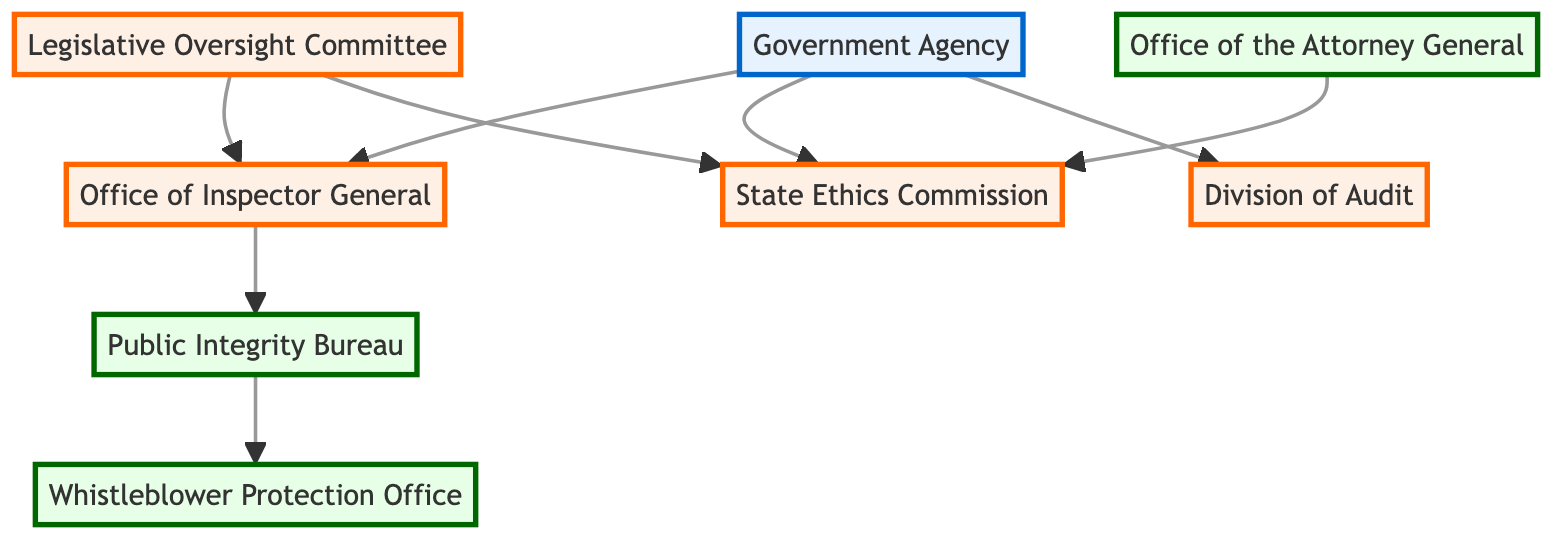What is the total number of nodes in the diagram? By counting each distinct node listed in the data, there are 8 nodes: Government Agency, Office of Inspector General, State Ethics Commission, Division of Audit, Legislative Oversight Committee, Whistleblower Protection Office, Public Integrity Bureau, and Office of the Attorney General.
Answer: 8 Which office reports directly to the Government Agency? The edges show that there are three offices that have a direct reporting line from the Government Agency: Office of Inspector General, State Ethics Commission, and Division of Audit.
Answer: Office of Inspector General, State Ethics Commission, Division of Audit How many offices are overseen by the Legislative Oversight Committee? The diagram shows that the Legislative Oversight Committee has direct connections to two offices: Office of Inspector General and State Ethics Commission.
Answer: 2 What is the role of the Public Integrity Bureau in the reporting structure? The Public Integrity Bureau is connected as a subordinate to the Office of Inspector General, indicating it's under its oversight. The next step from the Public Integrity Bureau connects to the Whistleblower Protection Office.
Answer: Subordinate to Office of Inspector General Which entity has connections to both the Ethics Commission and the Office of Inspector General? By tracing the edges, the Legislative Oversight Committee has direct lines leading to both the Ethics Commission and Office of Inspector General, indicating it has oversight over these offices.
Answer: Legislative Oversight Committee How many total edges are present in the diagram? Counting the connections (edges) in the data shows there are 8 edges illustrating the relationships between the various nodes. Each connection represents a reporting or oversight line.
Answer: 8 Which office is the last in the report hierarchy from Inspector General? Following the edges, the Inspector General is linked to the Public Integrity Bureau, which in turn reports to the Whistleblower Protection Office. Therefore, the Whistleblower Protection Office is the last in this hierarchical path.
Answer: Whistleblower Protection Office Which legal office connects to the State Ethics Commission? The Office of the Attorney General has a direct edge connecting to the State Ethics Commission, signifying its involvement in legal matters related to ethics oversight.
Answer: Office of the Attorney General 